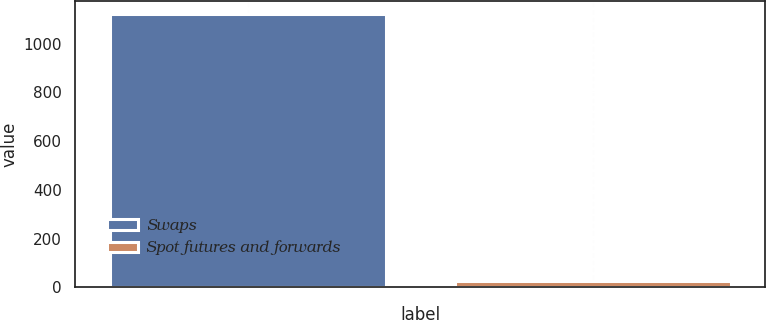<chart> <loc_0><loc_0><loc_500><loc_500><bar_chart><fcel>Swaps<fcel>Spot futures and forwards<nl><fcel>1121.3<fcel>24.6<nl></chart> 